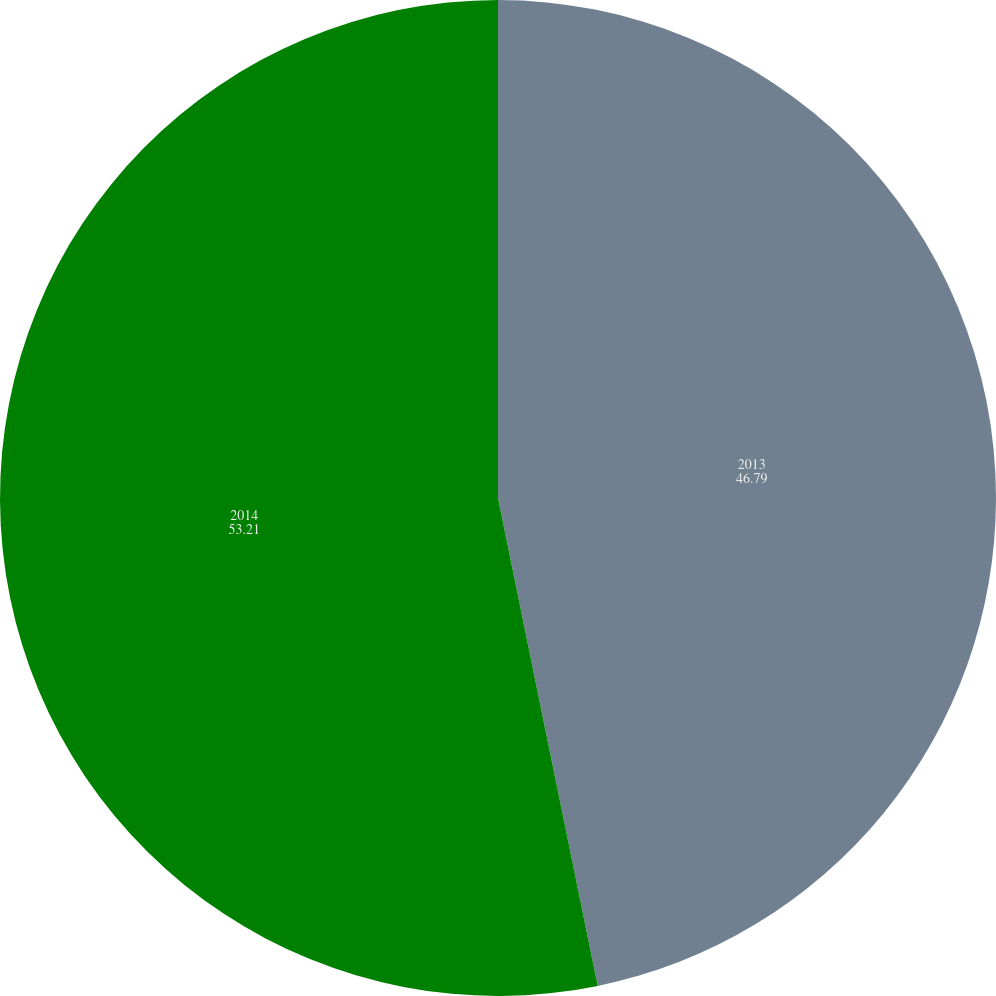Convert chart. <chart><loc_0><loc_0><loc_500><loc_500><pie_chart><fcel>2013<fcel>2014<nl><fcel>46.79%<fcel>53.21%<nl></chart> 